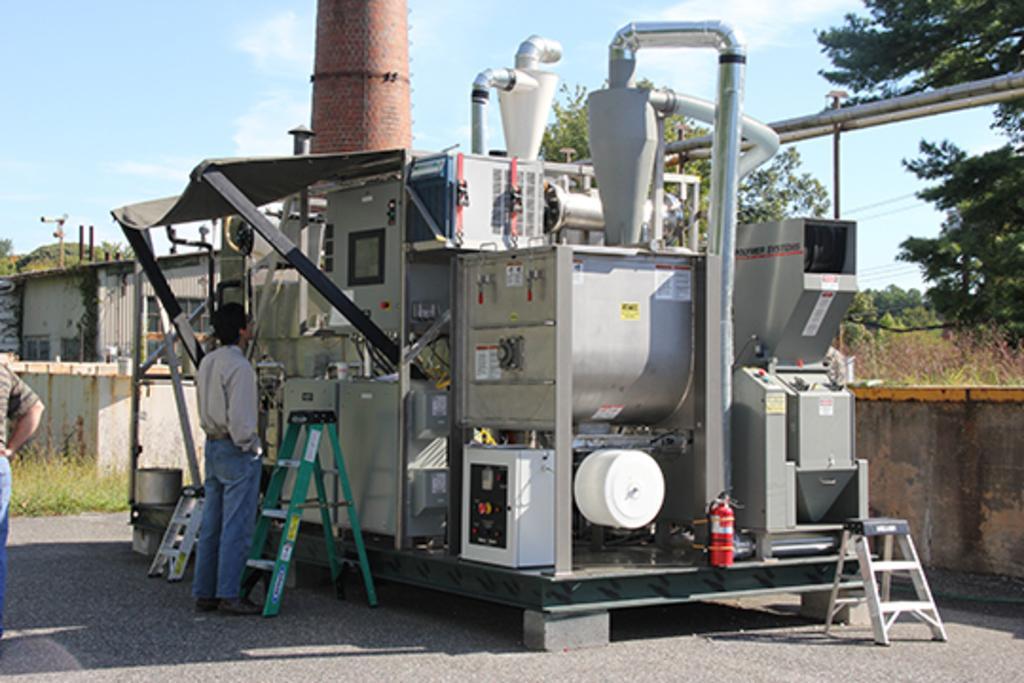Describe this image in one or two sentences. In this picture I can see there is a machine, there are two persons standing at left side, there are plants, trees and buildings in the backdrop. 